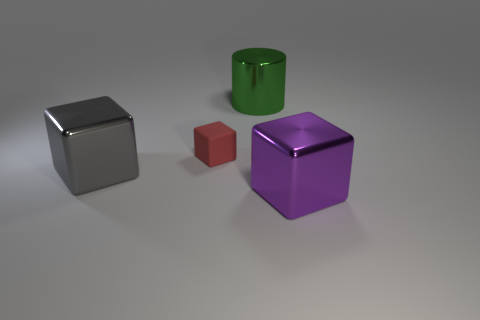What shape is the gray thing that is the same material as the green object?
Provide a succinct answer. Cube. There is a large green metal thing; is it the same shape as the big object left of the red object?
Keep it short and to the point. No. Does the metallic thing on the right side of the green object have the same shape as the tiny object?
Provide a short and direct response. Yes. Is there any other thing that has the same shape as the green thing?
Provide a short and direct response. No. How many small blue matte blocks are there?
Your answer should be compact. 0. There is a shiny cube that is on the left side of the thing in front of the gray metal block; how big is it?
Your answer should be compact. Large. What number of other things are the same size as the gray metal cube?
Your response must be concise. 2. There is a gray cube; how many tiny red matte objects are behind it?
Ensure brevity in your answer.  1. What size is the green metallic cylinder?
Provide a short and direct response. Large. Does the thing in front of the gray object have the same material as the big block that is on the left side of the purple metal object?
Your response must be concise. Yes. 